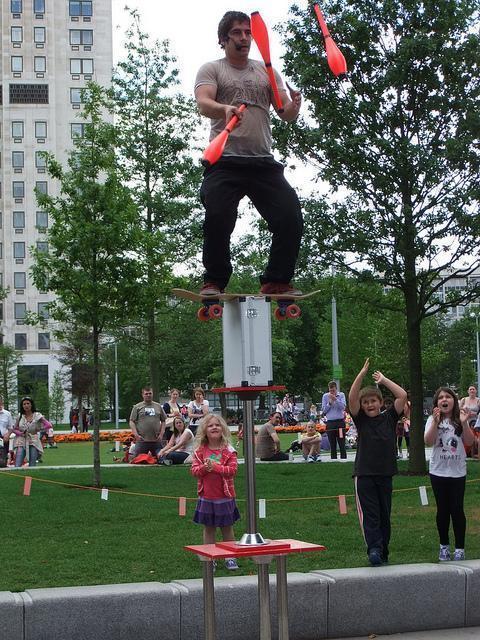How many pins are juggled up on top of the post by the man standing on the skateboard?
Choose the right answer from the provided options to respond to the question.
Options: Three, six, one, four. Three. 